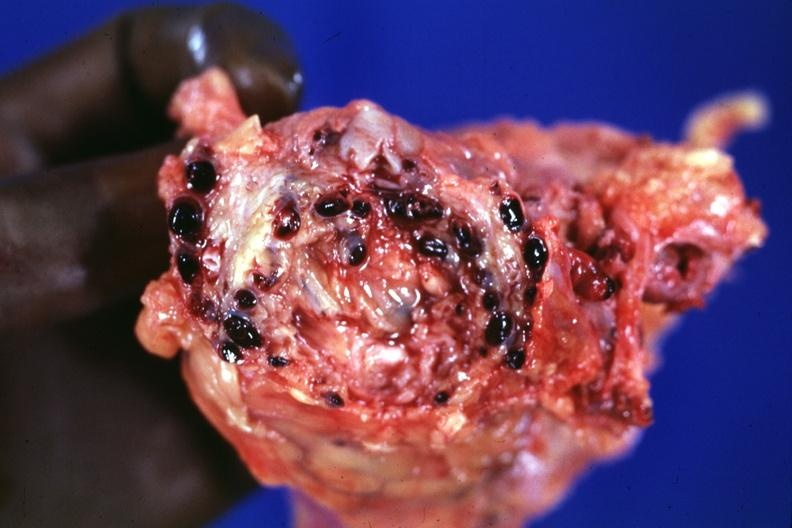what is present?
Answer the question using a single word or phrase. Venous thrombosis 